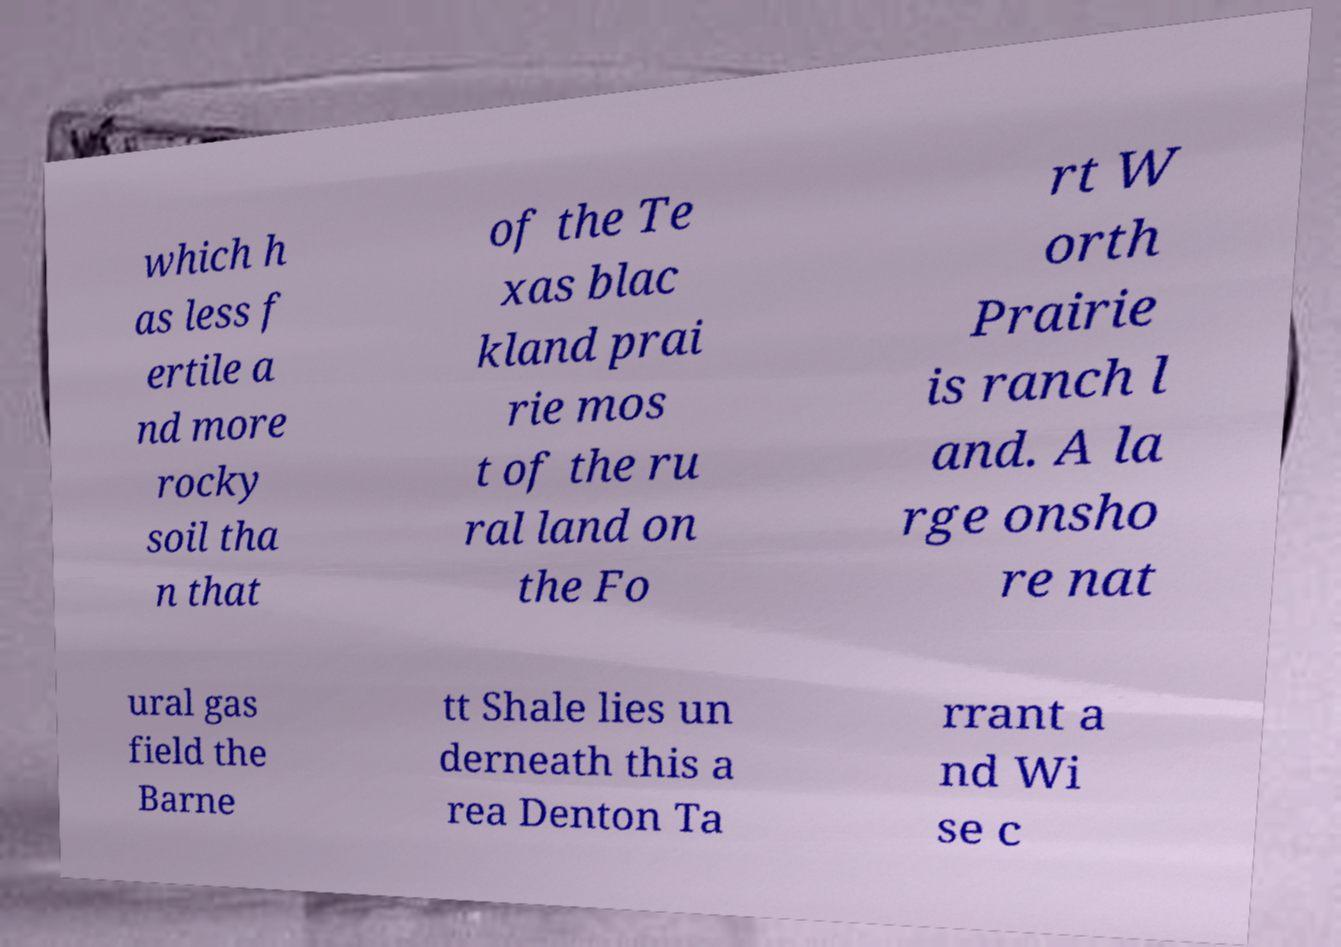Could you extract and type out the text from this image? which h as less f ertile a nd more rocky soil tha n that of the Te xas blac kland prai rie mos t of the ru ral land on the Fo rt W orth Prairie is ranch l and. A la rge onsho re nat ural gas field the Barne tt Shale lies un derneath this a rea Denton Ta rrant a nd Wi se c 